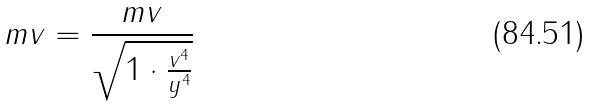Convert formula to latex. <formula><loc_0><loc_0><loc_500><loc_500>m v = \frac { m v } { \sqrt { 1 \cdot \frac { v ^ { 4 } } { y ^ { 4 } } } }</formula> 